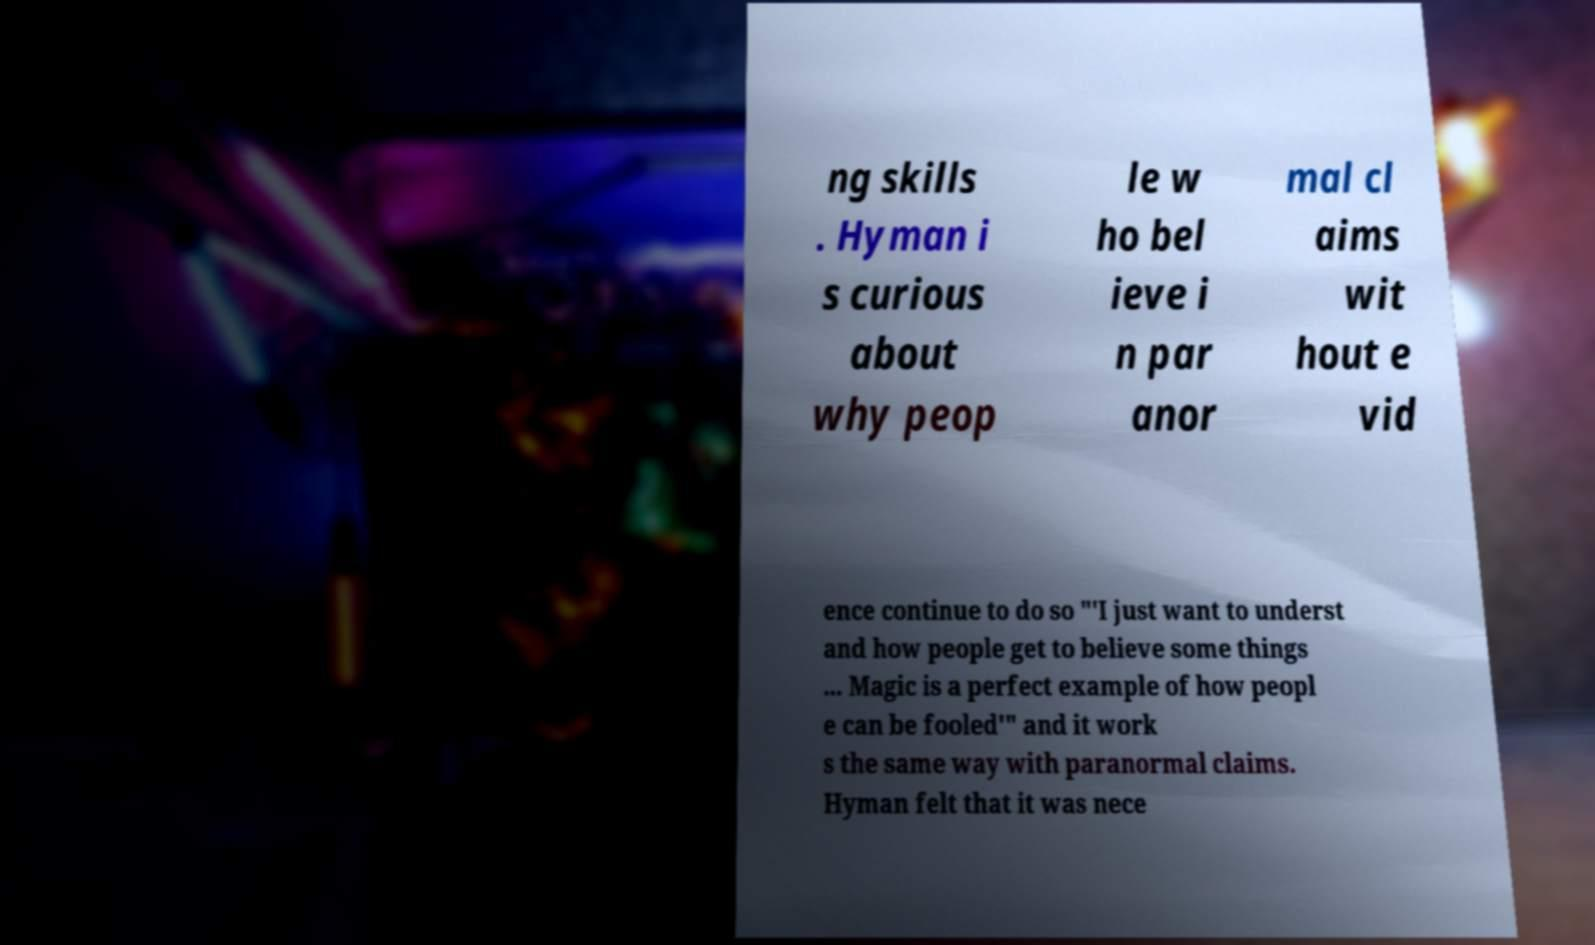What messages or text are displayed in this image? I need them in a readable, typed format. ng skills . Hyman i s curious about why peop le w ho bel ieve i n par anor mal cl aims wit hout e vid ence continue to do so "'I just want to underst and how people get to believe some things ... Magic is a perfect example of how peopl e can be fooled'" and it work s the same way with paranormal claims. Hyman felt that it was nece 